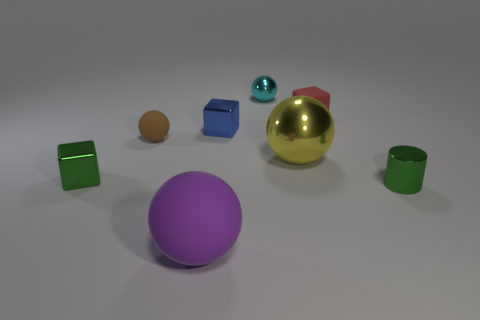Subtract all metallic blocks. How many blocks are left? 1 Subtract 2 spheres. How many spheres are left? 2 Subtract all cyan balls. How many balls are left? 3 Add 2 large purple matte things. How many objects exist? 10 Subtract all green balls. Subtract all red cylinders. How many balls are left? 4 Subtract all cubes. How many objects are left? 5 Add 6 small green shiny blocks. How many small green shiny blocks are left? 7 Add 8 tiny red matte things. How many tiny red matte things exist? 9 Subtract 0 purple cylinders. How many objects are left? 8 Subtract all large blocks. Subtract all cyan metal spheres. How many objects are left? 7 